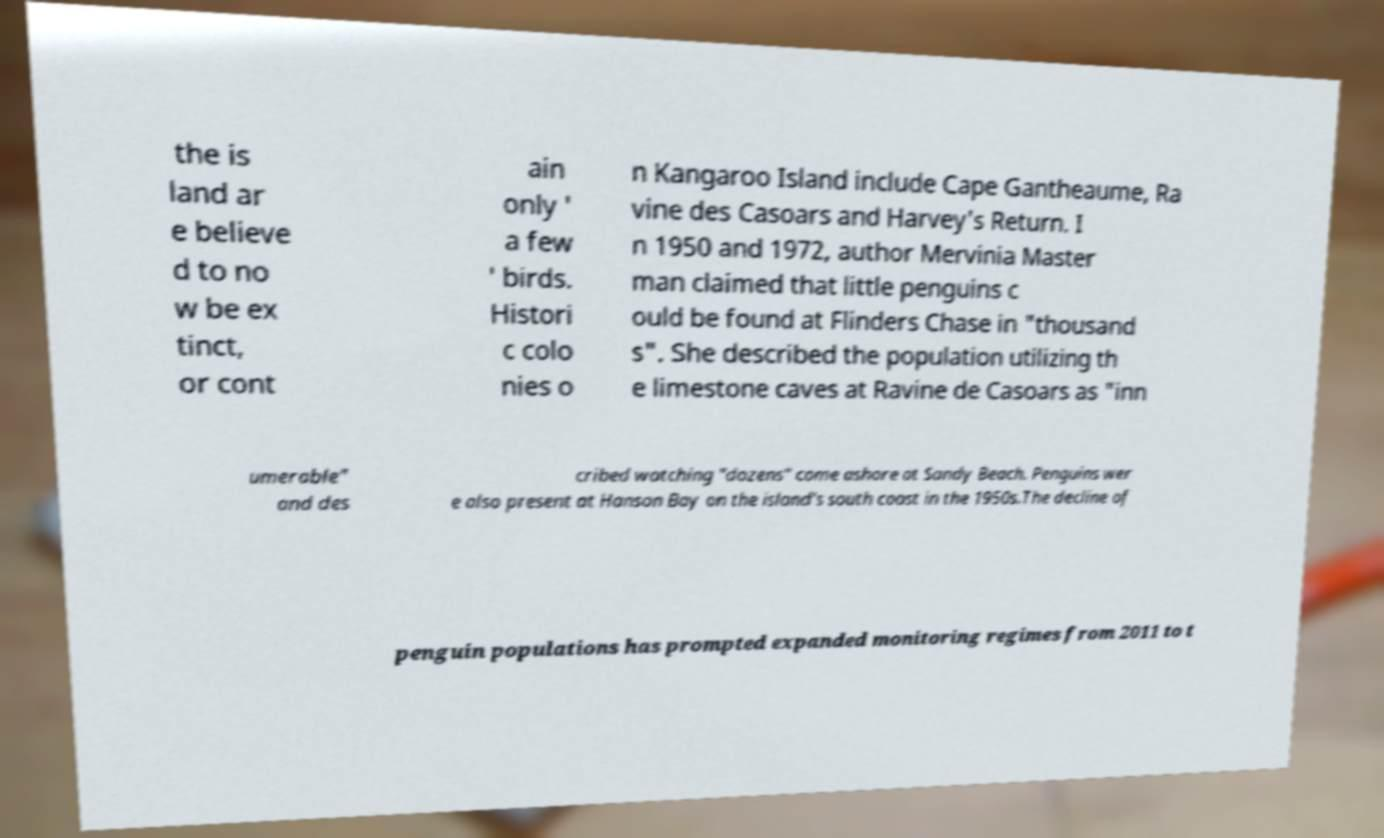For documentation purposes, I need the text within this image transcribed. Could you provide that? the is land ar e believe d to no w be ex tinct, or cont ain only ' a few ' birds. Histori c colo nies o n Kangaroo Island include Cape Gantheaume, Ra vine des Casoars and Harvey's Return. I n 1950 and 1972, author Mervinia Master man claimed that little penguins c ould be found at Flinders Chase in "thousand s". She described the population utilizing th e limestone caves at Ravine de Casoars as "inn umerable" and des cribed watching "dozens" come ashore at Sandy Beach. Penguins wer e also present at Hanson Bay on the island's south coast in the 1950s.The decline of penguin populations has prompted expanded monitoring regimes from 2011 to t 